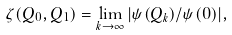Convert formula to latex. <formula><loc_0><loc_0><loc_500><loc_500>\zeta ( Q _ { 0 } , Q _ { 1 } ) = \lim _ { k \rightarrow \infty } | \psi ( Q _ { k } ) / \psi ( 0 ) | ,</formula> 